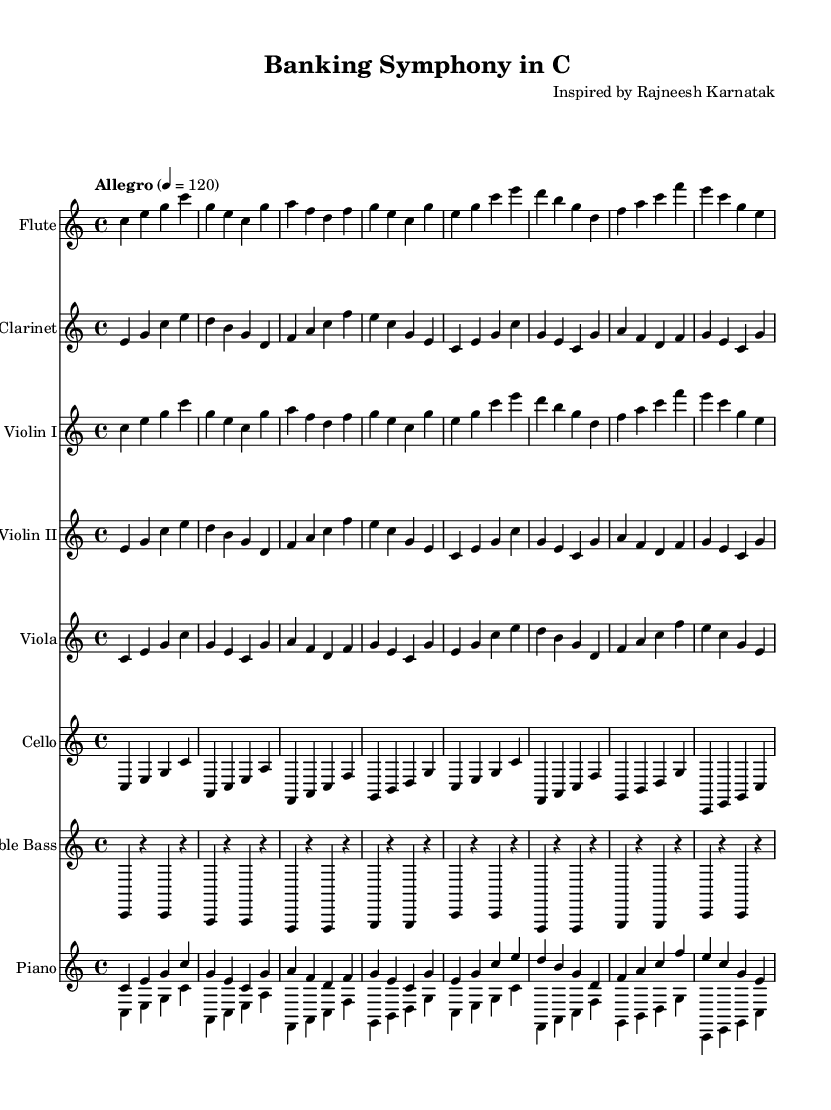What is the key signature of this music? The key signature is C major, which has no sharps or flats, indicated by the absence of any sharp or flat symbols at the beginning of the staff lines.
Answer: C major What is the time signature of this music? The time signature is 4/4, shown at the beginning of the sheet music where two numbers are stacked; the top number indicates four beats per measure, and the bottom number indicates a quarter note gets one beat.
Answer: 4/4 What is the tempo marking for this piece? The tempo marking is "Allegro," which indicates a fast and lively speed; additionally, it has a metronome marking of 120 beats per minute, specified next to it on the sheet music.
Answer: Allegro How many musical instruments are featured in this symphony? The score lists a total of eight instruments: Flute, Clarinet, Violin I, Violin II, Viola, Cello, Double Bass, and Piano, which are all present on separate staves in the printed music.
Answer: Eight Which instrument plays the first line? The Flute plays the first line, as it is the first staff listed in the score with its corresponding music notation appearing above the other instruments.
Answer: Flute What is the structure of the repeated musical phrases in this symphony? The symphony consists of musical phrases that follow a repetitive structure; for example, both the Flute and Violin I parts contain similar motifs repeated across measures, reflecting a minimalist approach to composition associated with banking efficiency.
Answer: Repetitive structure How does the piano part relate to the other instruments? The piano part is divided into two staves that typically play harmonic support and melodic lines, complementing the collective sound of the strings and woodwinds, similar to a supportive framework seen in banking operations.
Answer: Harmonic support 